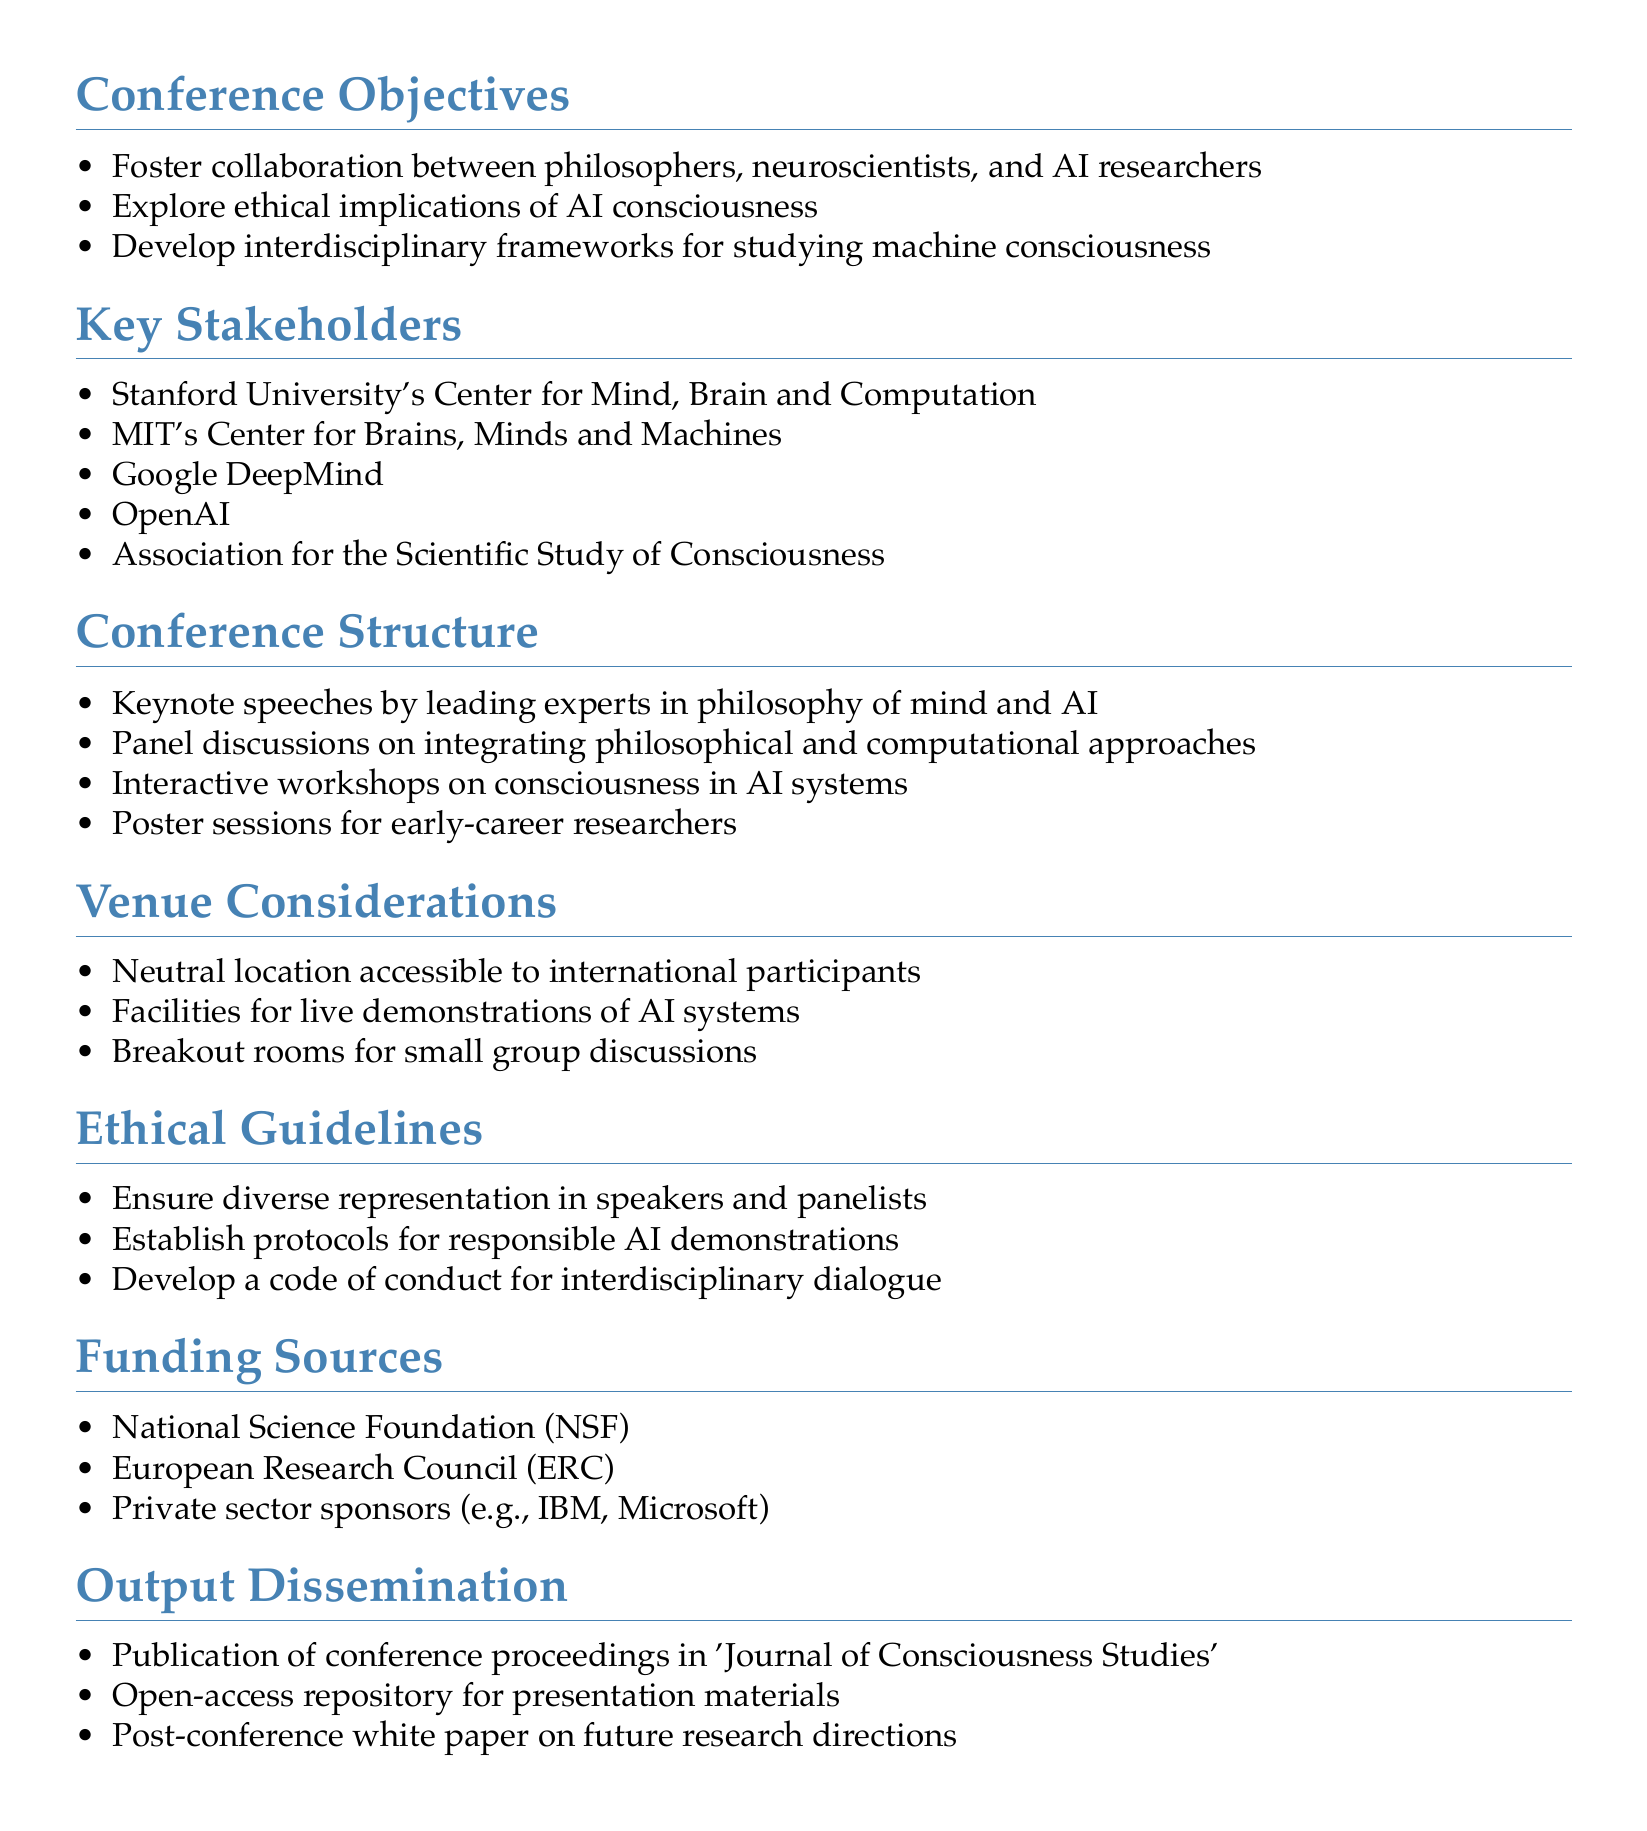What is the main objective of the conference? The main objective of the conference is to foster collaboration, explore ethical implications, and develop frameworks for interdisciplinary study around AI and consciousness.
Answer: Foster collaboration between philosophers, neuroscientists, and AI researchers Who is one of the key stakeholders listed in the document? A key stakeholder is an organization involved in the conference planning, one of which is mentioned in the document.
Answer: Stanford University's Center for Mind, Brain and Computation What type of session is included for early-career researchers? The document specifies various session types planned for the conference, highlighting one specifically for early-career researchers.
Answer: Poster sessions What is one ethical guideline mentioned in the document? An ethical guideline is a principle to ensure responsible behavior during the conference, and one is explicitly stated in the document.
Answer: Ensure diverse representation in speakers and panelists How many funding sources are listed in the document? The document enumerates various sources of funding, which can be counted to provide the total.
Answer: Three 